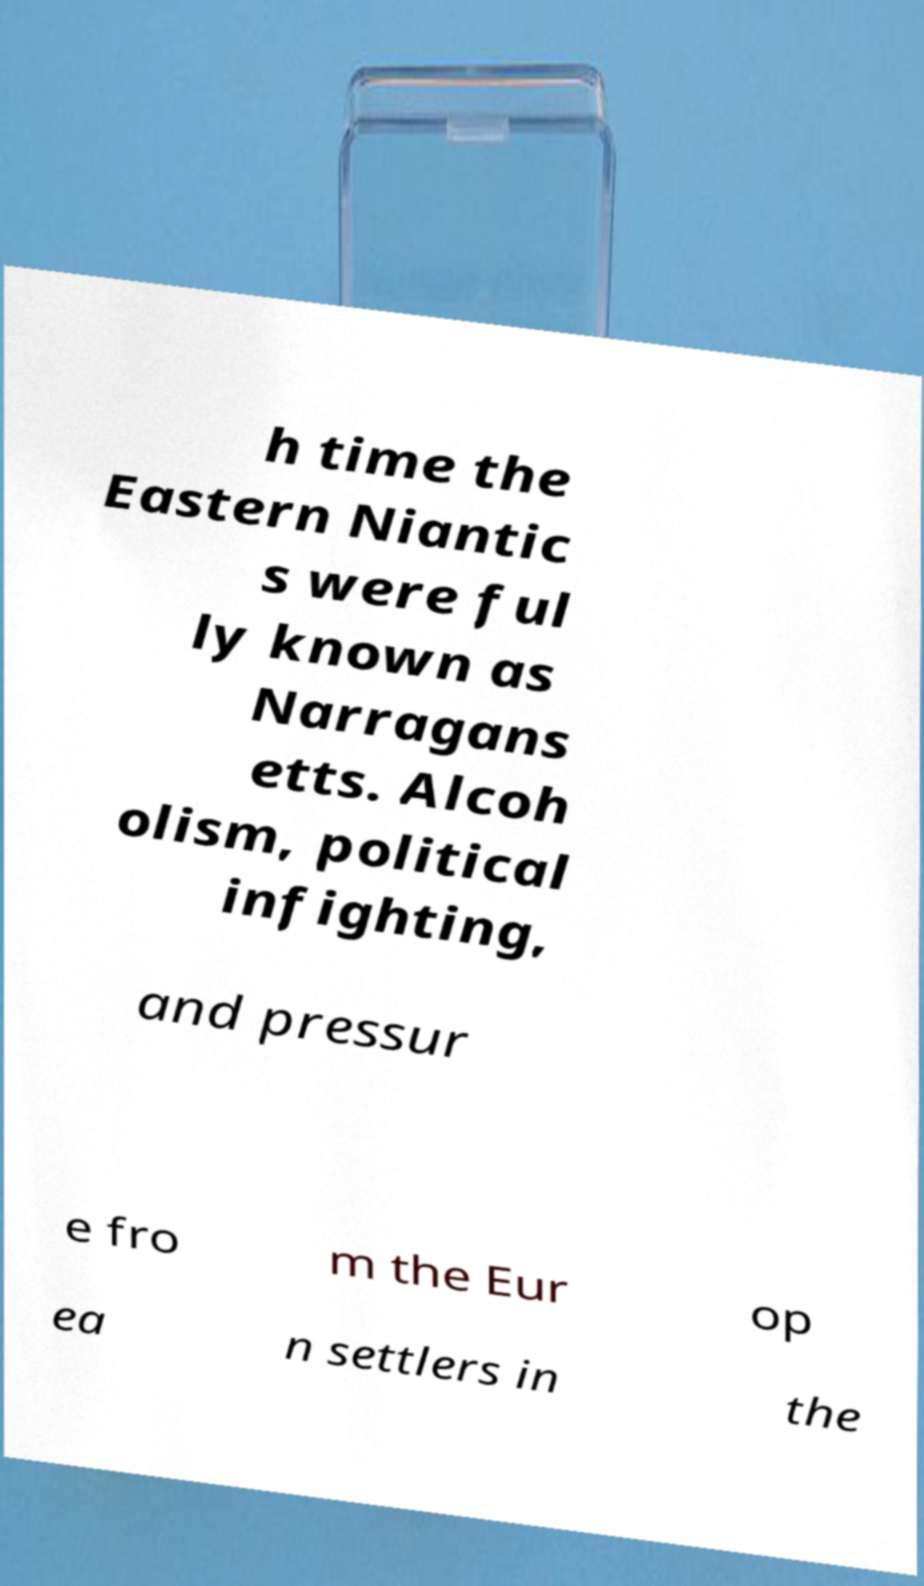Please read and relay the text visible in this image. What does it say? h time the Eastern Niantic s were ful ly known as Narragans etts. Alcoh olism, political infighting, and pressur e fro m the Eur op ea n settlers in the 